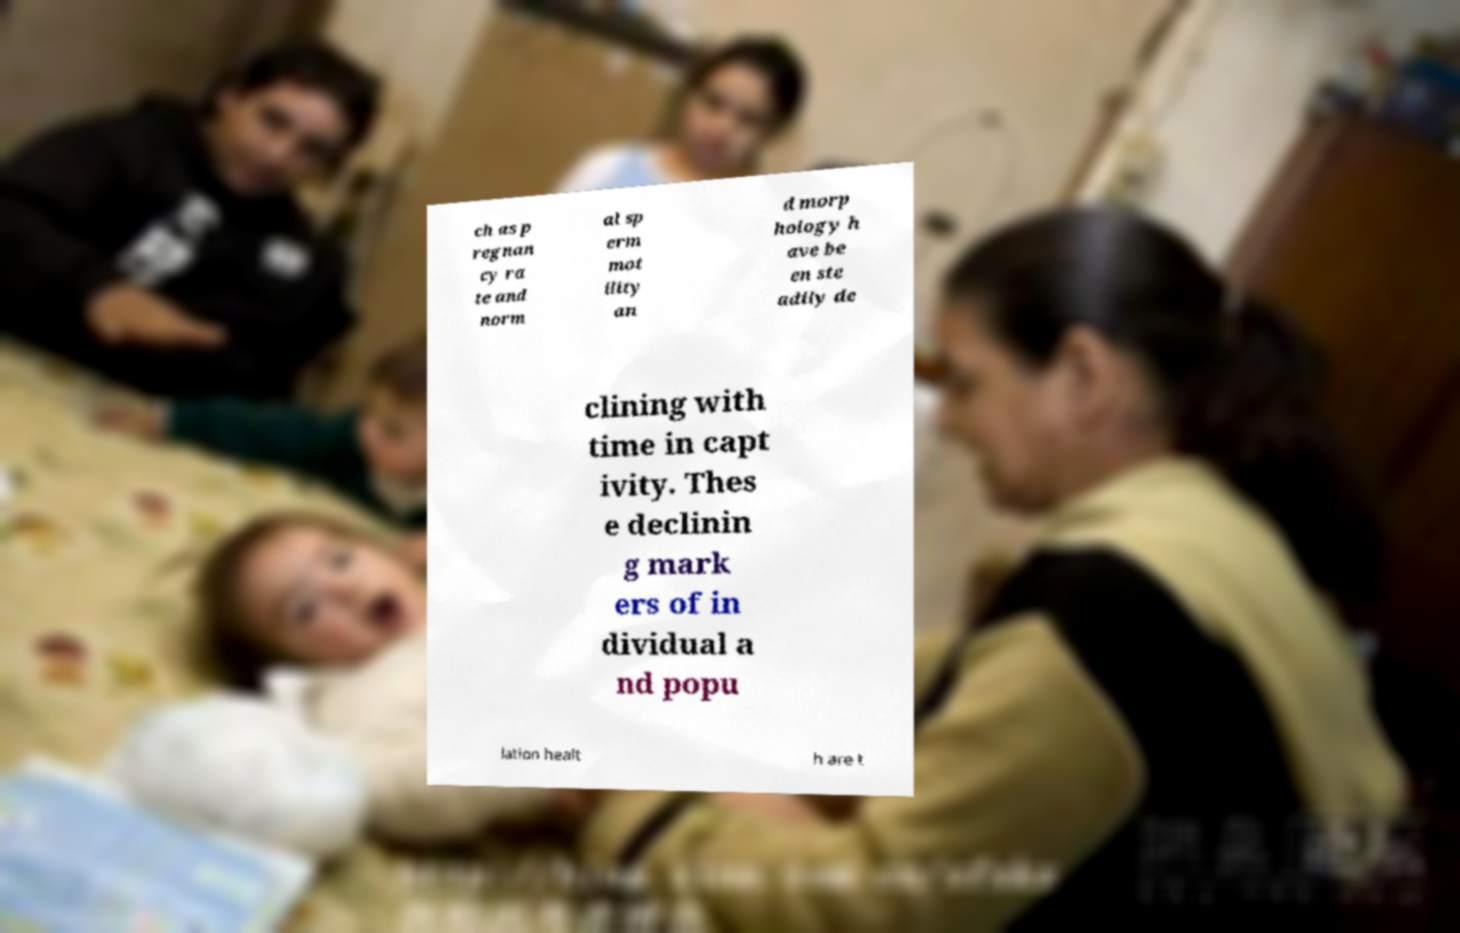Can you read and provide the text displayed in the image?This photo seems to have some interesting text. Can you extract and type it out for me? ch as p regnan cy ra te and norm al sp erm mot ility an d morp hology h ave be en ste adily de clining with time in capt ivity. Thes e declinin g mark ers of in dividual a nd popu lation healt h are t 